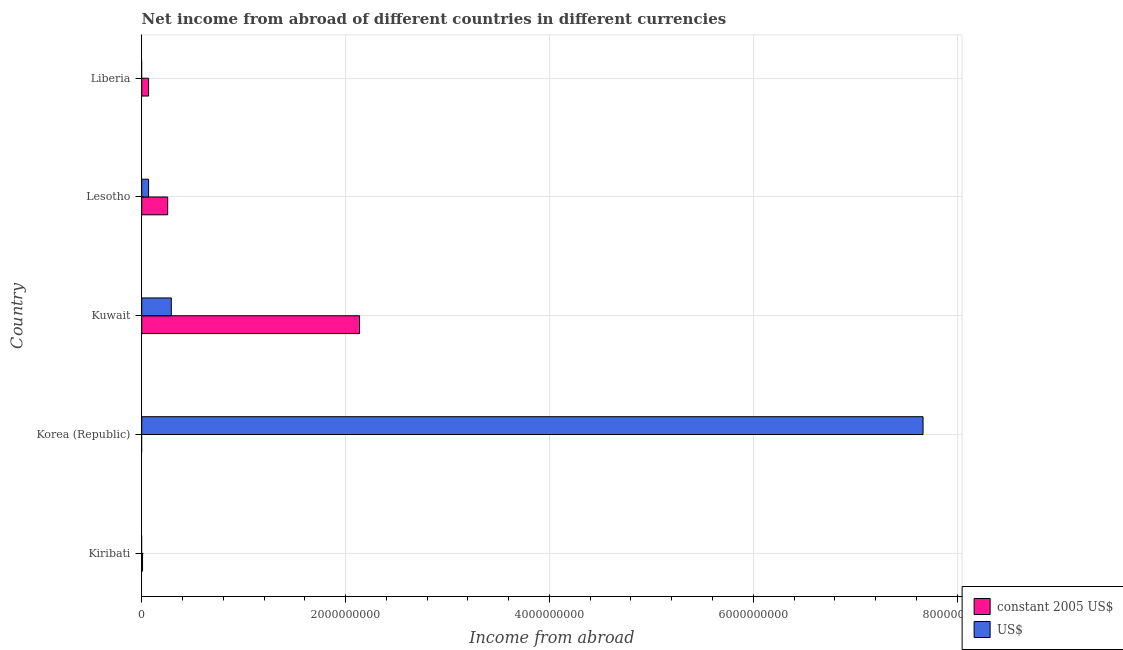How many bars are there on the 4th tick from the bottom?
Keep it short and to the point. 2. What is the label of the 4th group of bars from the top?
Ensure brevity in your answer.  Korea (Republic). In how many cases, is the number of bars for a given country not equal to the number of legend labels?
Provide a short and direct response. 3. What is the income from abroad in constant 2005 us$ in Liberia?
Make the answer very short. 6.73e+07. Across all countries, what is the maximum income from abroad in us$?
Provide a short and direct response. 7.67e+09. In which country was the income from abroad in us$ maximum?
Ensure brevity in your answer.  Korea (Republic). What is the total income from abroad in us$ in the graph?
Your answer should be compact. 8.02e+09. What is the difference between the income from abroad in constant 2005 us$ in Lesotho and that in Liberia?
Provide a short and direct response. 1.87e+08. What is the difference between the income from abroad in us$ in Lesotho and the income from abroad in constant 2005 us$ in Kiribati?
Your answer should be very brief. 5.93e+07. What is the average income from abroad in constant 2005 us$ per country?
Your answer should be compact. 4.93e+08. What is the difference between the income from abroad in constant 2005 us$ and income from abroad in us$ in Lesotho?
Your answer should be compact. 1.87e+08. In how many countries, is the income from abroad in constant 2005 us$ greater than 2800000000 units?
Offer a terse response. 0. What is the ratio of the income from abroad in us$ in Kuwait to that in Lesotho?
Offer a very short reply. 4.31. What is the difference between the highest and the second highest income from abroad in constant 2005 us$?
Give a very brief answer. 1.88e+09. What is the difference between the highest and the lowest income from abroad in us$?
Your answer should be very brief. 7.67e+09. In how many countries, is the income from abroad in us$ greater than the average income from abroad in us$ taken over all countries?
Give a very brief answer. 1. Is the sum of the income from abroad in us$ in Korea (Republic) and Lesotho greater than the maximum income from abroad in constant 2005 us$ across all countries?
Give a very brief answer. Yes. Are all the bars in the graph horizontal?
Offer a terse response. Yes. Does the graph contain any zero values?
Ensure brevity in your answer.  Yes. How many legend labels are there?
Your answer should be compact. 2. How are the legend labels stacked?
Offer a terse response. Vertical. What is the title of the graph?
Offer a very short reply. Net income from abroad of different countries in different currencies. Does "Infant" appear as one of the legend labels in the graph?
Give a very brief answer. No. What is the label or title of the X-axis?
Give a very brief answer. Income from abroad. What is the Income from abroad of constant 2005 US$ in Kiribati?
Provide a succinct answer. 8.06e+06. What is the Income from abroad of US$ in Kiribati?
Keep it short and to the point. 0. What is the Income from abroad of constant 2005 US$ in Korea (Republic)?
Your response must be concise. 0. What is the Income from abroad in US$ in Korea (Republic)?
Provide a succinct answer. 7.67e+09. What is the Income from abroad in constant 2005 US$ in Kuwait?
Ensure brevity in your answer.  2.14e+09. What is the Income from abroad of US$ in Kuwait?
Provide a succinct answer. 2.90e+08. What is the Income from abroad of constant 2005 US$ in Lesotho?
Ensure brevity in your answer.  2.55e+08. What is the Income from abroad in US$ in Lesotho?
Give a very brief answer. 6.73e+07. What is the Income from abroad of constant 2005 US$ in Liberia?
Your answer should be compact. 6.73e+07. Across all countries, what is the maximum Income from abroad in constant 2005 US$?
Provide a short and direct response. 2.14e+09. Across all countries, what is the maximum Income from abroad of US$?
Provide a short and direct response. 7.67e+09. What is the total Income from abroad of constant 2005 US$ in the graph?
Offer a very short reply. 2.47e+09. What is the total Income from abroad of US$ in the graph?
Offer a very short reply. 8.02e+09. What is the difference between the Income from abroad in constant 2005 US$ in Kiribati and that in Kuwait?
Make the answer very short. -2.13e+09. What is the difference between the Income from abroad of constant 2005 US$ in Kiribati and that in Lesotho?
Ensure brevity in your answer.  -2.47e+08. What is the difference between the Income from abroad of constant 2005 US$ in Kiribati and that in Liberia?
Your answer should be very brief. -5.93e+07. What is the difference between the Income from abroad of US$ in Korea (Republic) and that in Kuwait?
Your response must be concise. 7.38e+09. What is the difference between the Income from abroad in US$ in Korea (Republic) and that in Lesotho?
Offer a terse response. 7.60e+09. What is the difference between the Income from abroad of constant 2005 US$ in Kuwait and that in Lesotho?
Your response must be concise. 1.88e+09. What is the difference between the Income from abroad in US$ in Kuwait and that in Lesotho?
Make the answer very short. 2.23e+08. What is the difference between the Income from abroad in constant 2005 US$ in Kuwait and that in Liberia?
Make the answer very short. 2.07e+09. What is the difference between the Income from abroad of constant 2005 US$ in Lesotho and that in Liberia?
Offer a very short reply. 1.87e+08. What is the difference between the Income from abroad in constant 2005 US$ in Kiribati and the Income from abroad in US$ in Korea (Republic)?
Offer a very short reply. -7.66e+09. What is the difference between the Income from abroad in constant 2005 US$ in Kiribati and the Income from abroad in US$ in Kuwait?
Provide a short and direct response. -2.82e+08. What is the difference between the Income from abroad of constant 2005 US$ in Kiribati and the Income from abroad of US$ in Lesotho?
Provide a short and direct response. -5.93e+07. What is the difference between the Income from abroad in constant 2005 US$ in Kuwait and the Income from abroad in US$ in Lesotho?
Provide a short and direct response. 2.07e+09. What is the average Income from abroad in constant 2005 US$ per country?
Offer a terse response. 4.93e+08. What is the average Income from abroad in US$ per country?
Ensure brevity in your answer.  1.60e+09. What is the difference between the Income from abroad of constant 2005 US$ and Income from abroad of US$ in Kuwait?
Keep it short and to the point. 1.85e+09. What is the difference between the Income from abroad of constant 2005 US$ and Income from abroad of US$ in Lesotho?
Offer a terse response. 1.87e+08. What is the ratio of the Income from abroad in constant 2005 US$ in Kiribati to that in Kuwait?
Offer a terse response. 0. What is the ratio of the Income from abroad in constant 2005 US$ in Kiribati to that in Lesotho?
Your answer should be compact. 0.03. What is the ratio of the Income from abroad of constant 2005 US$ in Kiribati to that in Liberia?
Your answer should be compact. 0.12. What is the ratio of the Income from abroad of US$ in Korea (Republic) to that in Kuwait?
Your answer should be compact. 26.4. What is the ratio of the Income from abroad in US$ in Korea (Republic) to that in Lesotho?
Your response must be concise. 113.82. What is the ratio of the Income from abroad in constant 2005 US$ in Kuwait to that in Lesotho?
Offer a terse response. 8.39. What is the ratio of the Income from abroad in US$ in Kuwait to that in Lesotho?
Provide a succinct answer. 4.31. What is the ratio of the Income from abroad of constant 2005 US$ in Kuwait to that in Liberia?
Offer a terse response. 31.73. What is the ratio of the Income from abroad of constant 2005 US$ in Lesotho to that in Liberia?
Offer a very short reply. 3.78. What is the difference between the highest and the second highest Income from abroad in constant 2005 US$?
Give a very brief answer. 1.88e+09. What is the difference between the highest and the second highest Income from abroad in US$?
Provide a short and direct response. 7.38e+09. What is the difference between the highest and the lowest Income from abroad of constant 2005 US$?
Offer a very short reply. 2.14e+09. What is the difference between the highest and the lowest Income from abroad in US$?
Provide a short and direct response. 7.67e+09. 